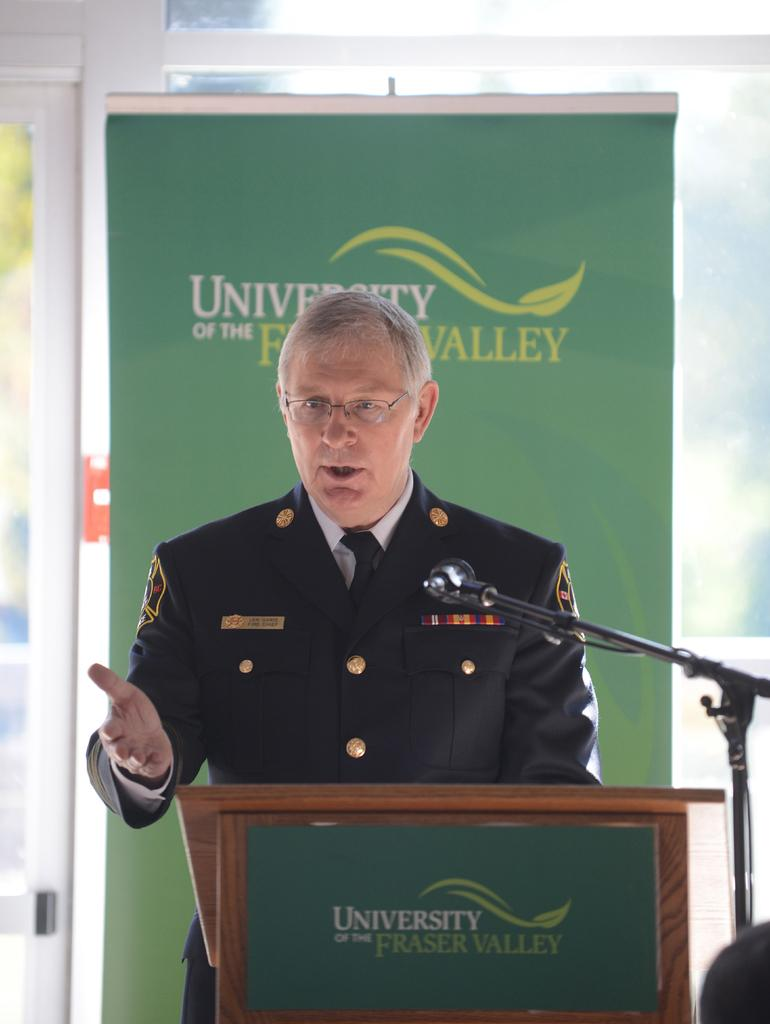What is the main subject in the foreground of the image? There is a man standing in the foreground of the image. What is the man standing in front of? The man is in front of a podium. What can be seen near the man in the foreground? There is a mic stand in the foreground. What is visible in the background of the image? There is a banner and a glass wall in the background. What type of oatmeal is being served at the event in the image? There is no indication of oatmeal or any food being served in the image. What degree does the man have, as indicated by the badge on his chest? There is no badge or any indication of a degree in the image. 